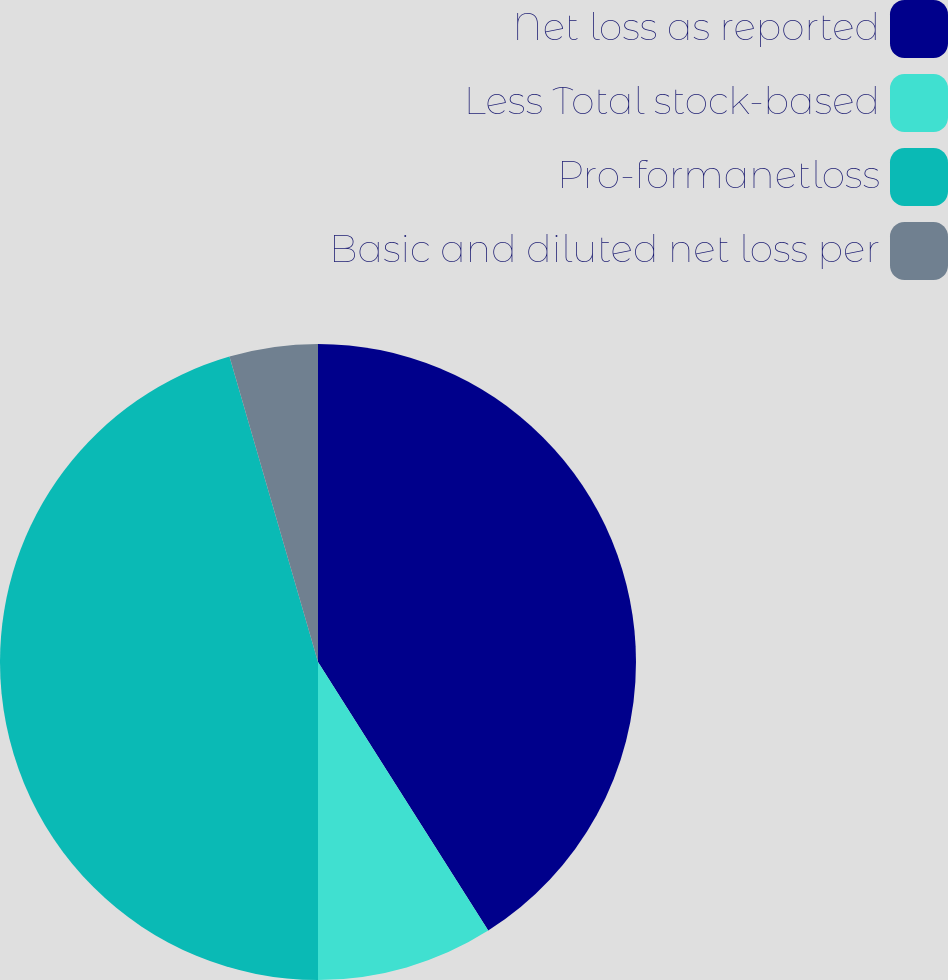<chart> <loc_0><loc_0><loc_500><loc_500><pie_chart><fcel>Net loss as reported<fcel>Less Total stock-based<fcel>Pro-formanetloss<fcel>Basic and diluted net loss per<nl><fcel>41.01%<fcel>8.99%<fcel>45.51%<fcel>4.49%<nl></chart> 